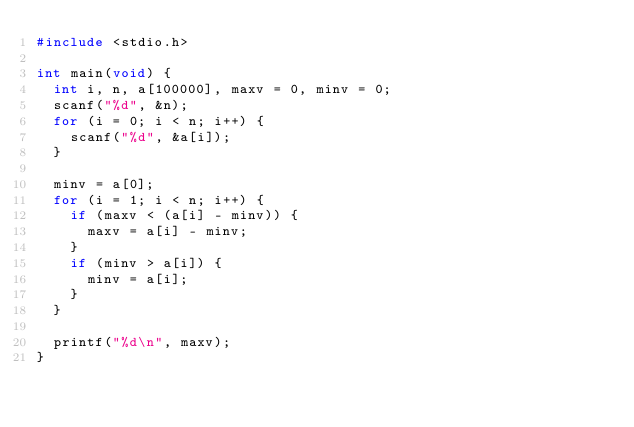<code> <loc_0><loc_0><loc_500><loc_500><_C_>#include <stdio.h>

int main(void) {
  int i, n, a[100000], maxv = 0, minv = 0;
  scanf("%d", &n);
  for (i = 0; i < n; i++) {
    scanf("%d", &a[i]);
  }

  minv = a[0];
  for (i = 1; i < n; i++) {
    if (maxv < (a[i] - minv)) {
      maxv = a[i] - minv;
    }
    if (minv > a[i]) {
      minv = a[i];
    }
  }

  printf("%d\n", maxv);
}

</code> 